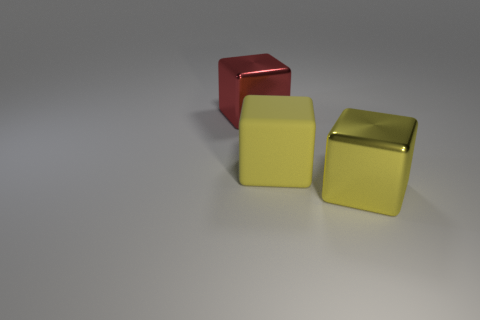There is another thing that is the same color as the big matte thing; what is it made of?
Provide a short and direct response. Metal. Do the shiny thing behind the big matte object and the yellow metallic thing have the same shape?
Give a very brief answer. Yes. What material is the big red thing that is the same shape as the yellow rubber object?
Offer a very short reply. Metal. What number of things are either blocks that are to the right of the red object or metallic blocks that are behind the large yellow metallic block?
Provide a short and direct response. 3. Does the large matte cube have the same color as the big shiny block behind the big yellow metal cube?
Offer a very short reply. No. What is the shape of the big object that is the same material as the red cube?
Ensure brevity in your answer.  Cube. What number of yellow shiny objects are there?
Give a very brief answer. 1. How many things are either shiny cubes that are on the left side of the rubber cube or big red blocks?
Offer a very short reply. 1. Does the metal block left of the yellow metal thing have the same color as the matte block?
Keep it short and to the point. No. How many other objects are the same color as the large rubber thing?
Offer a terse response. 1. 